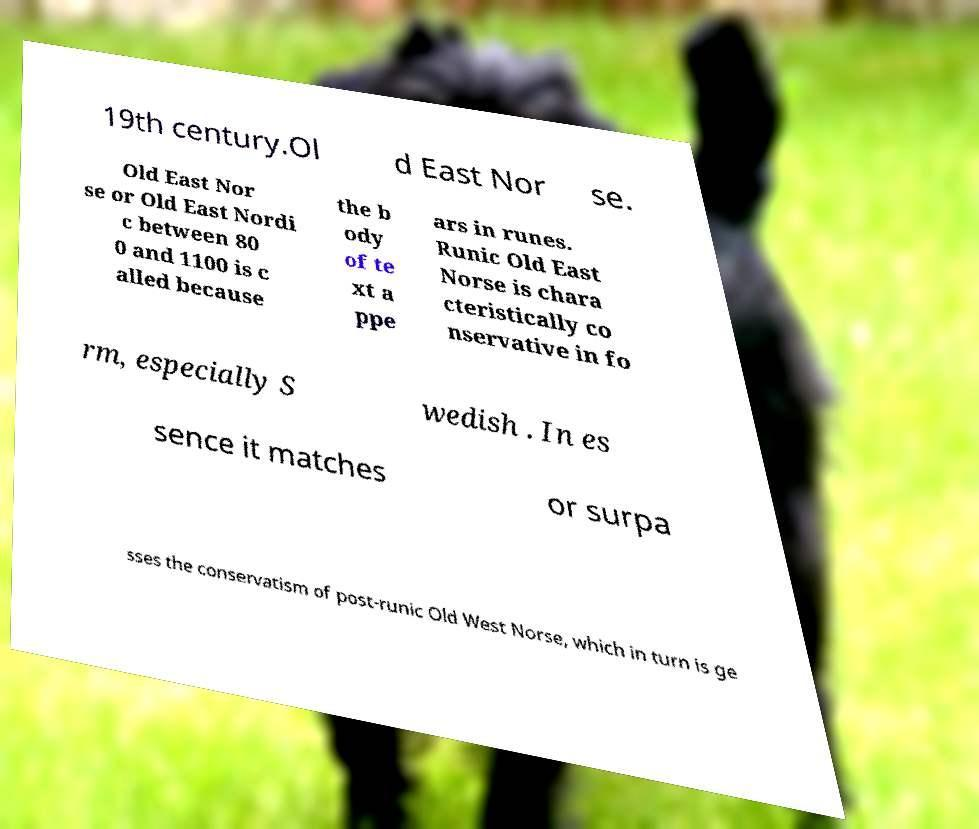Could you extract and type out the text from this image? 19th century.Ol d East Nor se. Old East Nor se or Old East Nordi c between 80 0 and 1100 is c alled because the b ody of te xt a ppe ars in runes. Runic Old East Norse is chara cteristically co nservative in fo rm, especially S wedish . In es sence it matches or surpa sses the conservatism of post-runic Old West Norse, which in turn is ge 